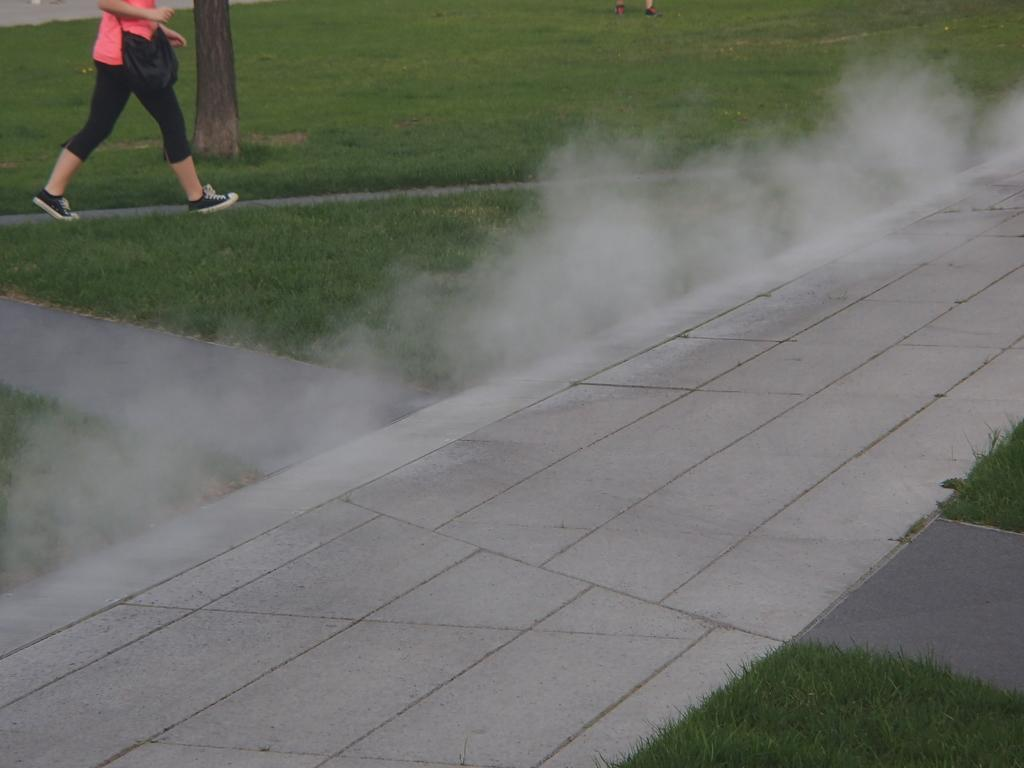What is present in the image? There is a person in the image. What is the person wearing? The person is wearing a bag. What is the person doing in the image? The person is walking. What type of terrain can be seen in the image? There is grass in the image. What other object can be seen in the image? There is a branch in the image. What else is visible in the image? There is smoke in the image. What type of tank can be seen on the side of the person in the image? There is no tank present in the image, and the person is not shown with a tank on their side. 